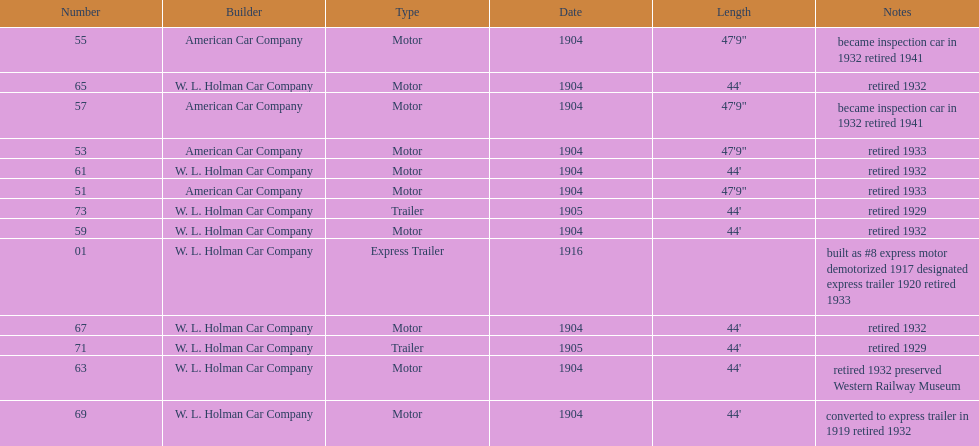What was the total number of cars listed? 13. 